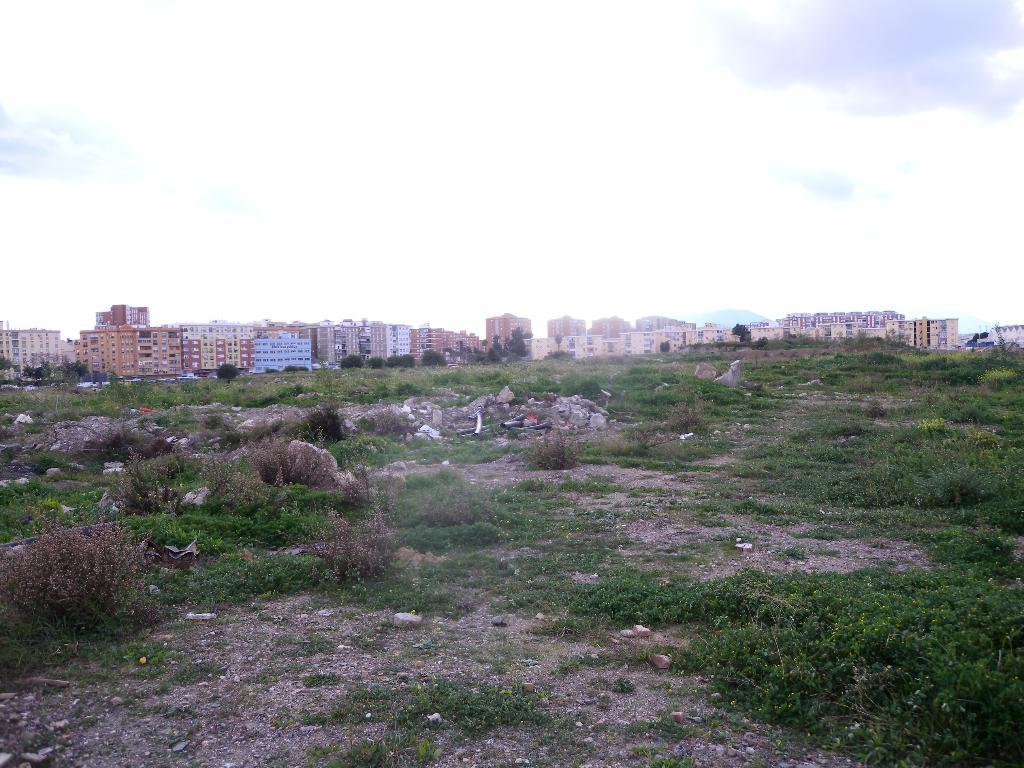What can be seen at the bottom of the image? There are trees and stones at the bottom of the image. What is located in the middle of the image? There are big buildings in the middle of the image. What is visible at the top of the image? The sky is visible at the top of the image. Where can we find the toothpaste in the image? There is no toothpaste present in the image. What type of lunch is being served in the image? There is no lunch depicted in the image. 